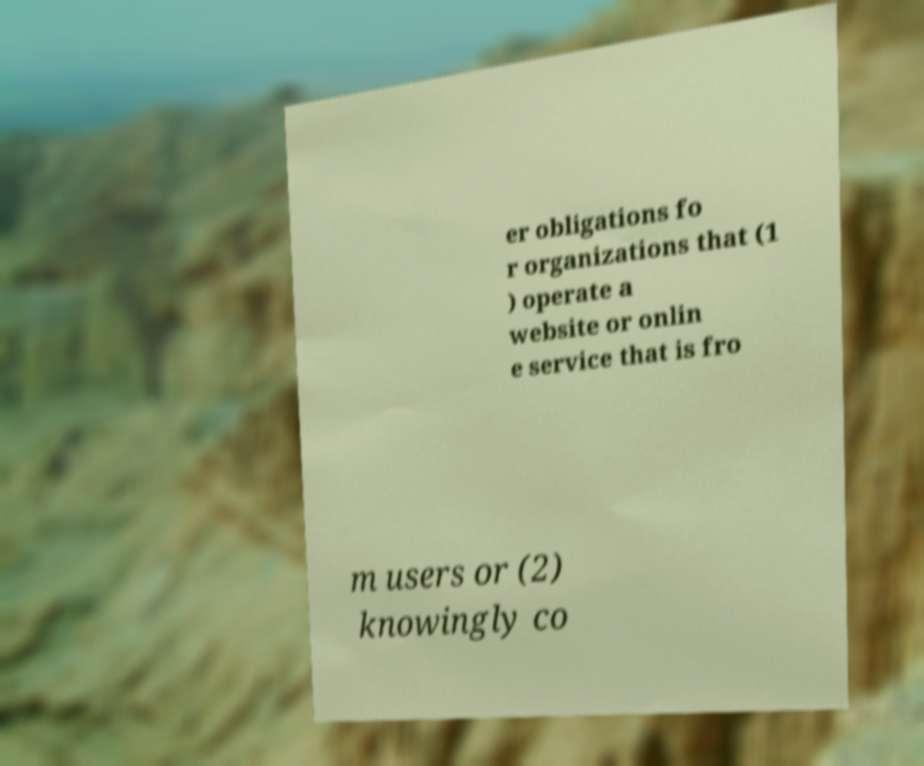Could you assist in decoding the text presented in this image and type it out clearly? er obligations fo r organizations that (1 ) operate a website or onlin e service that is fro m users or (2) knowingly co 